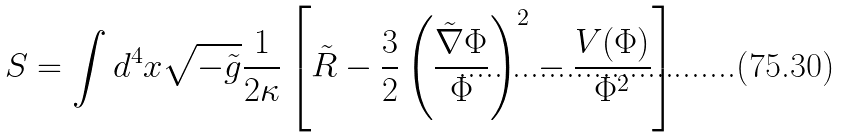<formula> <loc_0><loc_0><loc_500><loc_500>S = \int d ^ { 4 } x { \sqrt { - { \tilde { g } } } } { \frac { 1 } { 2 \kappa } } \left [ { \tilde { R } } - { \frac { 3 } { 2 } } \left ( { \frac { { \tilde { \nabla } } \Phi } { \Phi } } \right ) ^ { 2 } - { \frac { V ( \Phi ) } { \Phi ^ { 2 } } } \right ]</formula> 